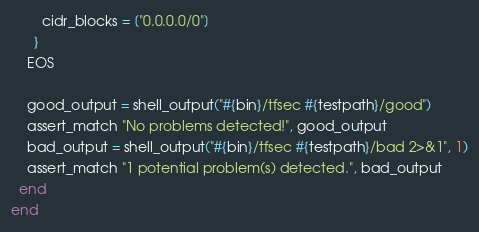<code> <loc_0><loc_0><loc_500><loc_500><_Ruby_>        cidr_blocks = ["0.0.0.0/0"]
      }
    EOS

    good_output = shell_output("#{bin}/tfsec #{testpath}/good")
    assert_match "No problems detected!", good_output
    bad_output = shell_output("#{bin}/tfsec #{testpath}/bad 2>&1", 1)
    assert_match "1 potential problem(s) detected.", bad_output
  end
end
</code> 